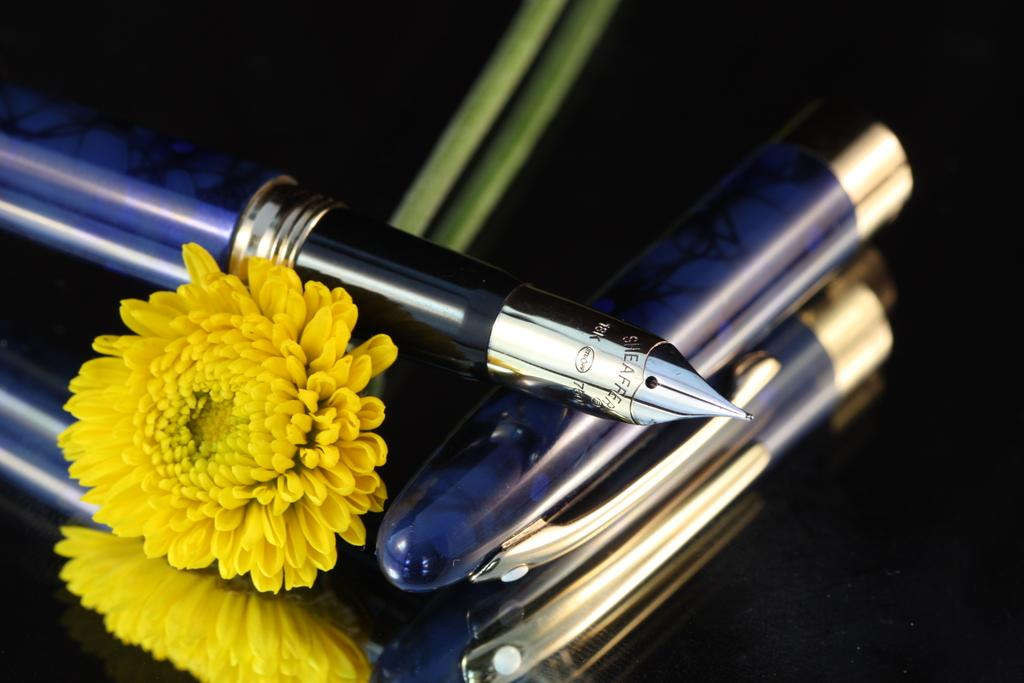What type of plant is in the image? There is a flower in the image. What writing instrument is in the image? There is a pen in the image. What type of clothing accessory is in the image? There is a cap in the image. What is the color of the surface the objects are on? The objects are on a black surface. What can be seen in the image besides the objects themselves? The reflection of the objects is visible in the image. What type of chess piece is located on the side of the image? There is no chess piece present in the image. What type of bait is used to attract the flower in the image? The flower is not a living creature that requires bait; it is a plant. 